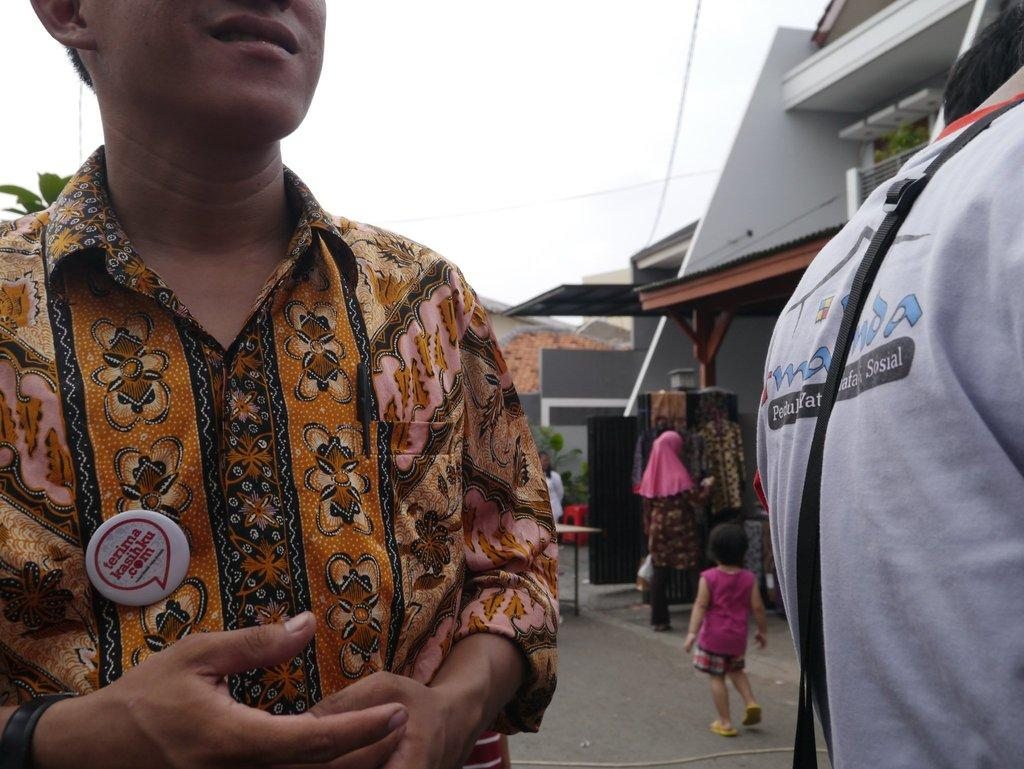What is happening on the road in the image? There are persons on the road in the image. What can be seen in the background of the image? Clothes, persons, buildings, and the sky are visible in the background of the image. Can you describe the setting of the image? The image shows a scene with people on the road, surrounded by buildings and a sky in the background. What type of fruit is being used as a base for the meat in the image? There is no fruit or meat present in the image; it features persons on the road and a background with clothes, persons, buildings, and the sky. 